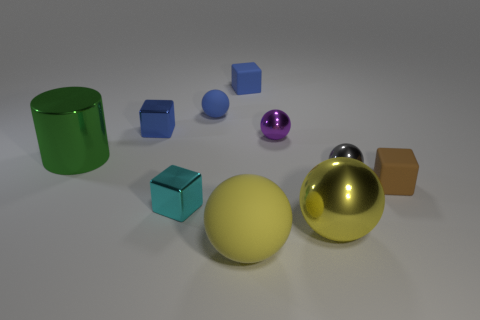There is a metal sphere that is in front of the tiny brown rubber object; is its size the same as the shiny sphere behind the gray sphere?
Make the answer very short. No. There is a blue matte object to the right of the large yellow matte thing; what is its shape?
Your answer should be very brief. Cube. There is a small blue cube behind the blue cube in front of the blue ball; what is its material?
Give a very brief answer. Rubber. Are there any shiny cylinders of the same color as the big matte ball?
Your response must be concise. No. There is a gray thing; is its size the same as the cyan shiny thing that is behind the yellow metallic object?
Offer a terse response. Yes. How many large green shiny cylinders are right of the big object that is on the right side of the matte sphere that is in front of the yellow shiny object?
Give a very brief answer. 0. There is a green metal cylinder; what number of small purple spheres are left of it?
Make the answer very short. 0. What is the color of the metal block that is in front of the large metal thing on the left side of the tiny blue ball?
Provide a succinct answer. Cyan. What number of other objects are there of the same material as the green thing?
Your answer should be very brief. 5. Are there the same number of brown cubes behind the large rubber object and small blue matte spheres?
Provide a short and direct response. Yes. 